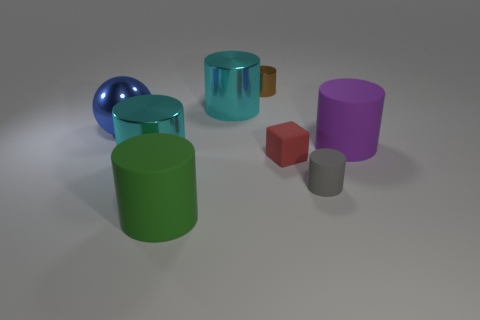The metallic cylinder that is the same size as the matte cube is what color?
Offer a terse response. Brown. Are there fewer brown shiny cylinders right of the small brown object than red matte blocks that are on the left side of the big green rubber thing?
Provide a short and direct response. No. What number of large metallic cylinders are behind the cyan thing in front of the big cylinder on the right side of the brown shiny cylinder?
Your answer should be very brief. 1. What size is the gray thing that is the same shape as the big purple object?
Provide a succinct answer. Small. Is there any other thing that is the same size as the purple matte thing?
Give a very brief answer. Yes. Are there fewer blue metallic things that are in front of the brown thing than metallic cylinders?
Provide a succinct answer. Yes. Do the tiny brown metallic object and the red thing have the same shape?
Ensure brevity in your answer.  No. What color is the other big rubber thing that is the same shape as the green object?
Keep it short and to the point. Purple. How many things are big rubber objects that are on the left side of the gray matte object or big yellow rubber cylinders?
Offer a very short reply. 1. There is a gray cylinder that is on the right side of the large metallic sphere; what is its size?
Offer a very short reply. Small. 